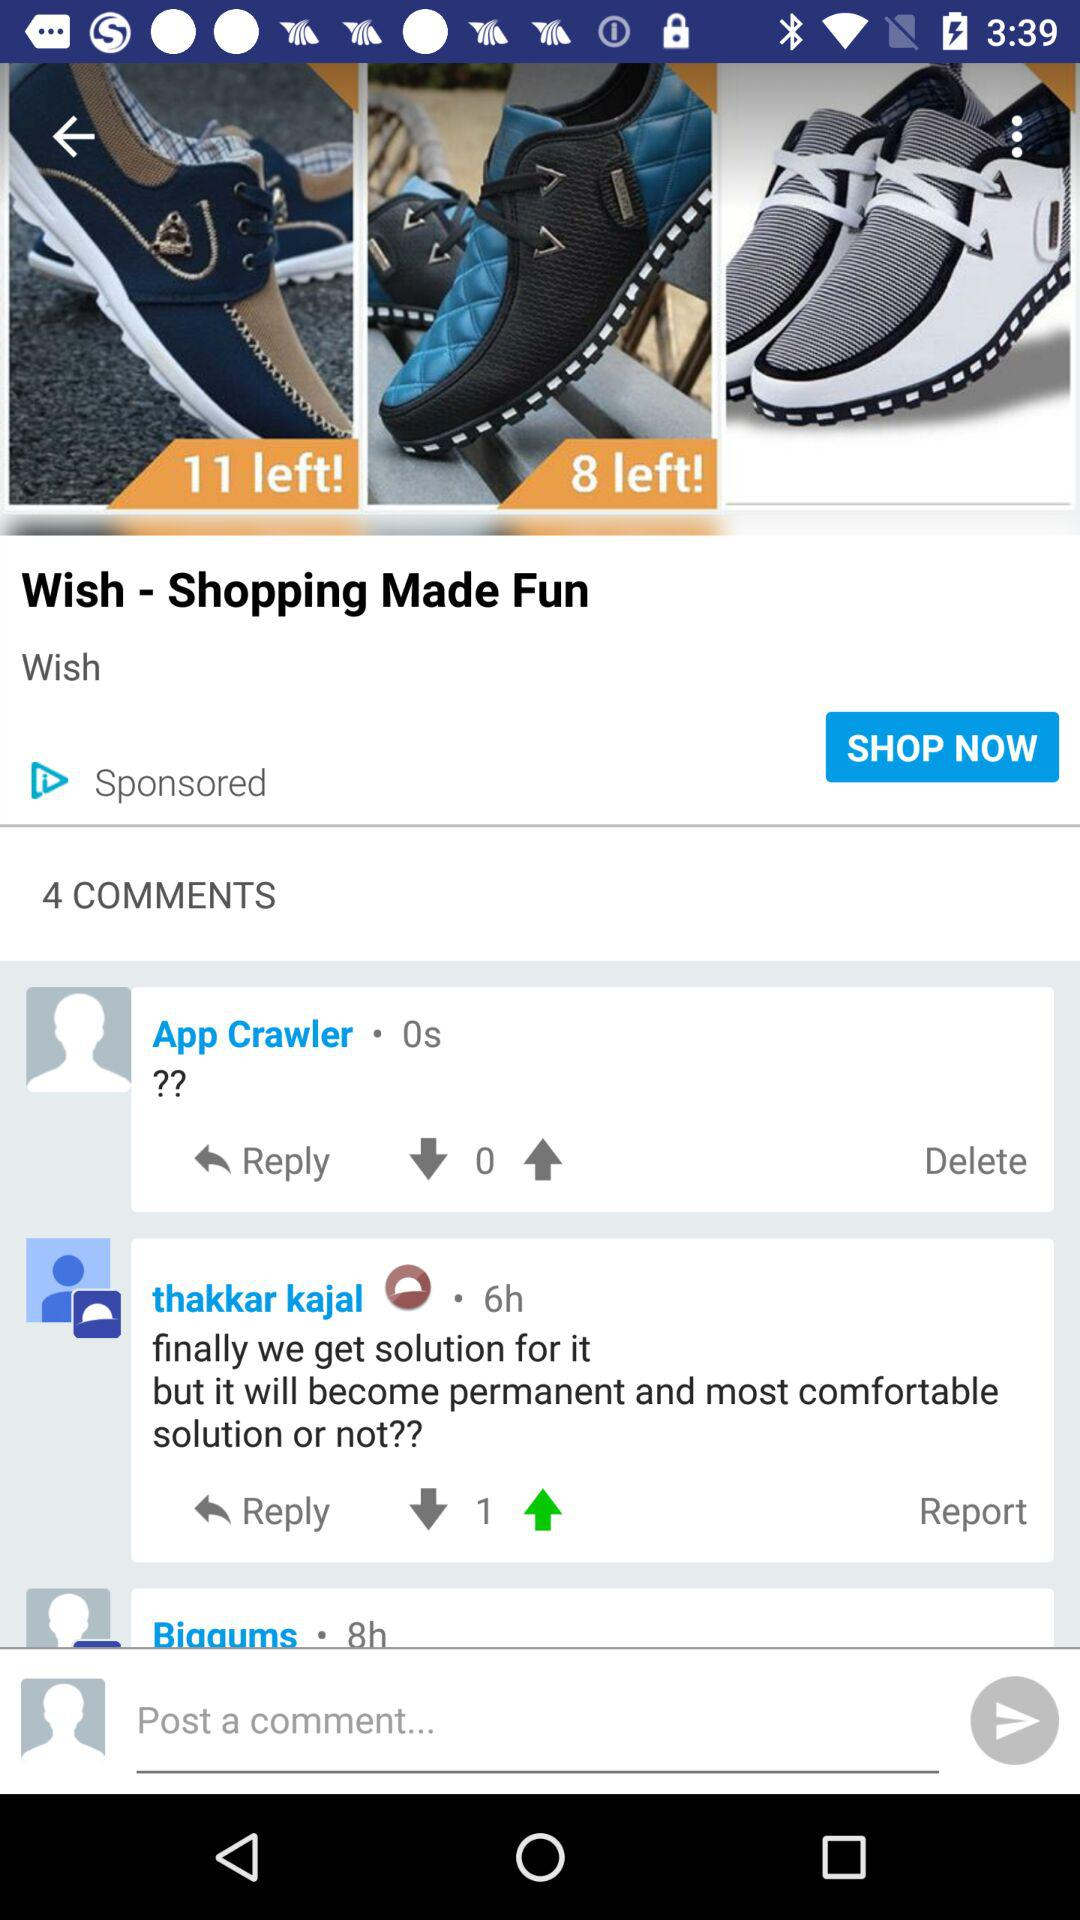When did Thakkar Kajal comment? Thakkar Kajal commented 6 hours ago. 